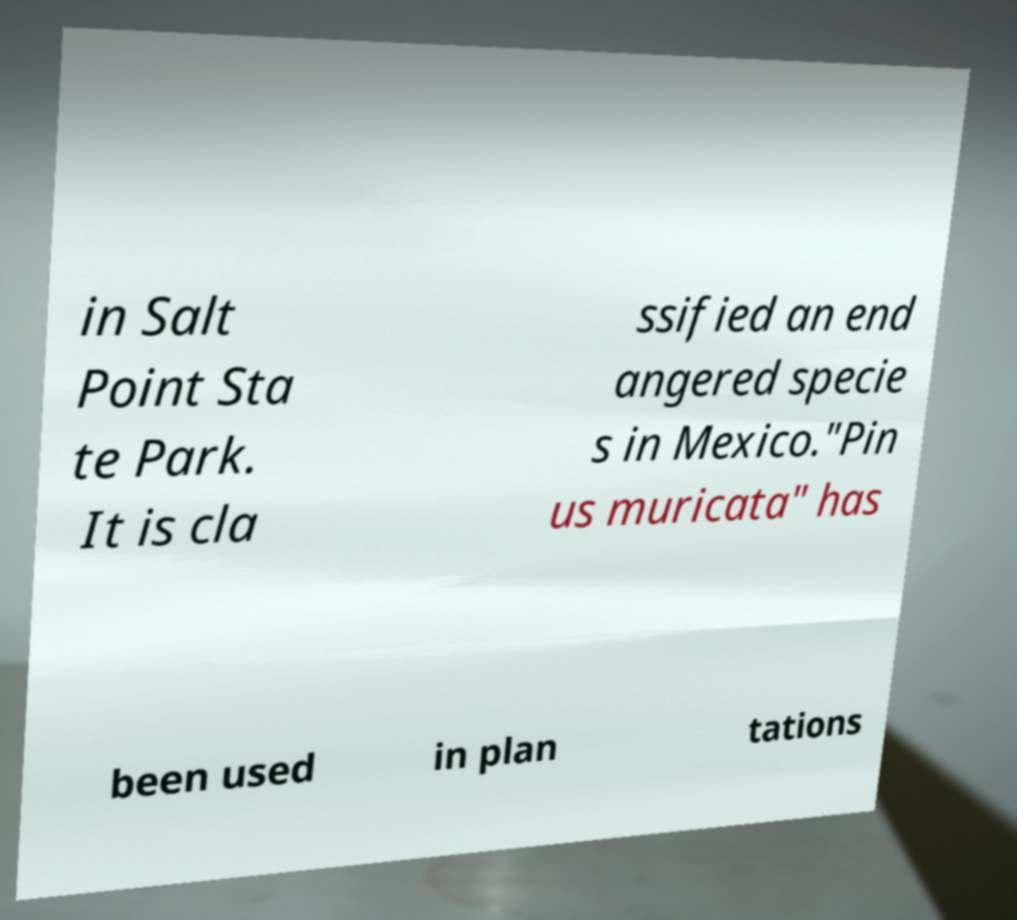What messages or text are displayed in this image? I need them in a readable, typed format. in Salt Point Sta te Park. It is cla ssified an end angered specie s in Mexico."Pin us muricata" has been used in plan tations 